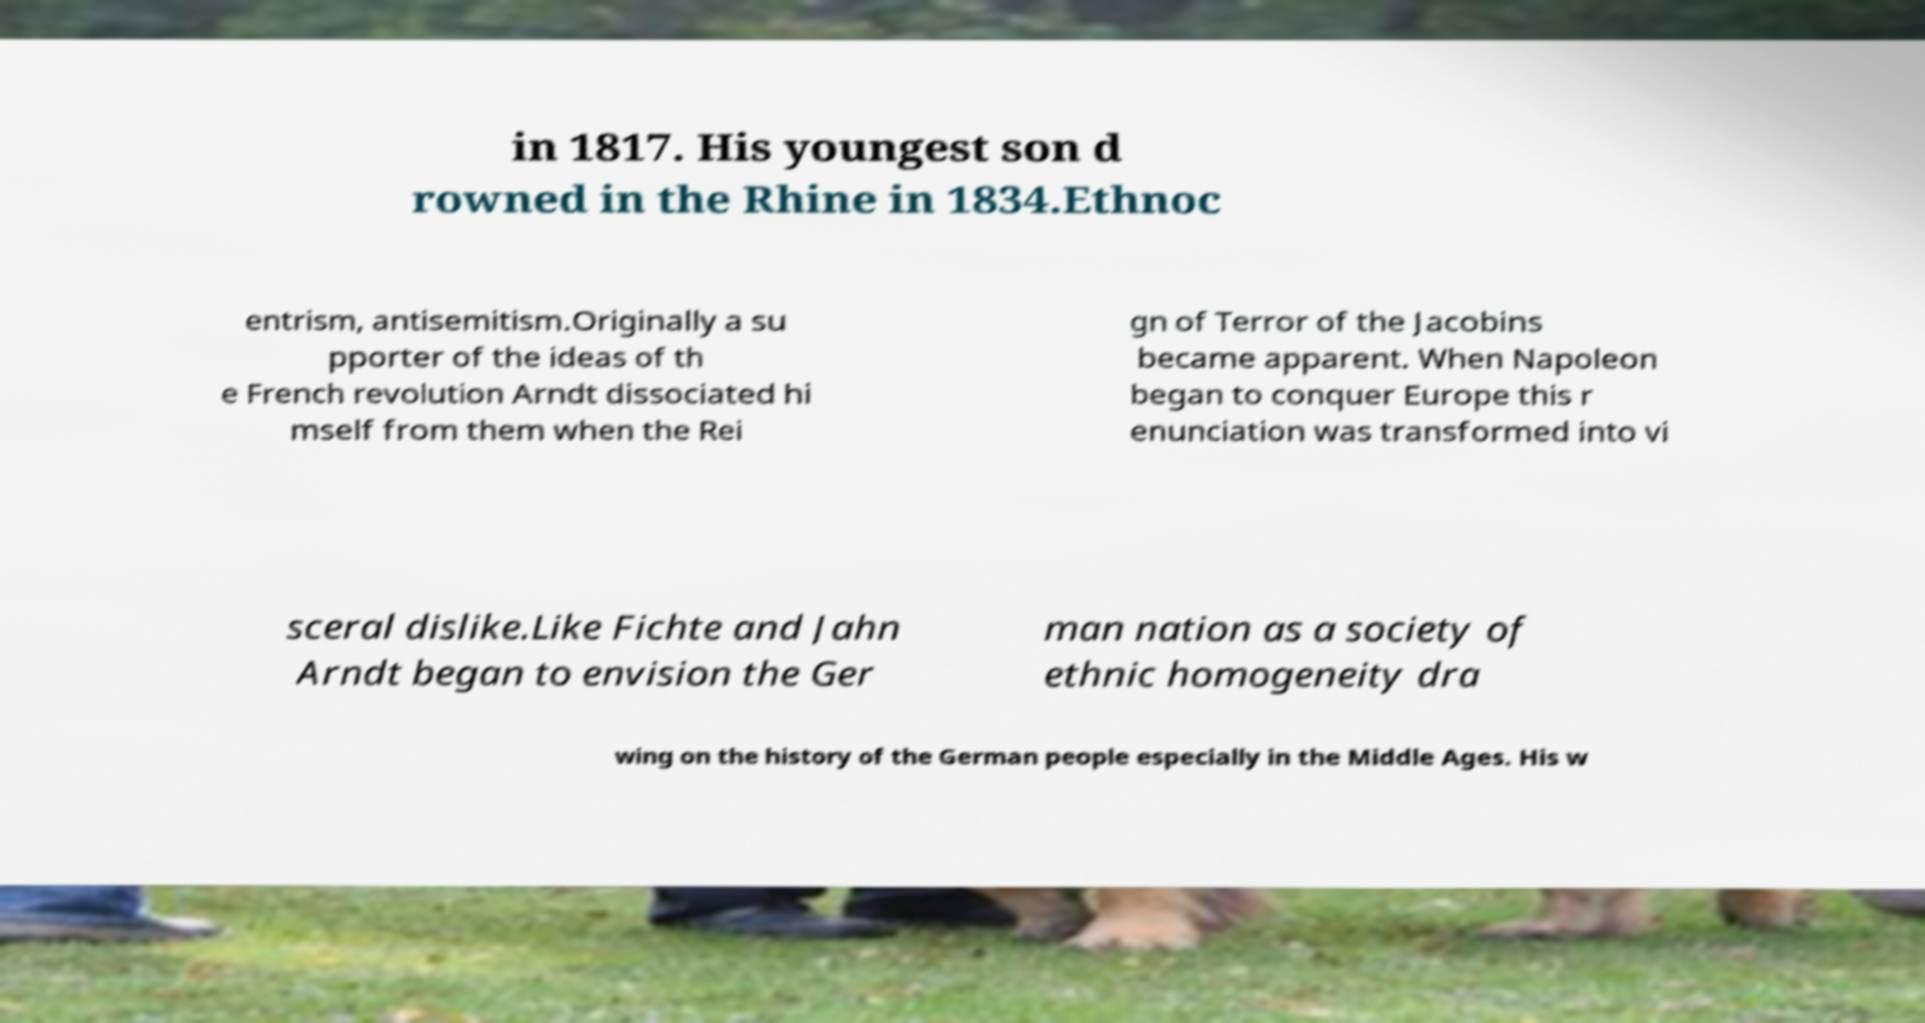There's text embedded in this image that I need extracted. Can you transcribe it verbatim? in 1817. His youngest son d rowned in the Rhine in 1834.Ethnoc entrism, antisemitism.Originally a su pporter of the ideas of th e French revolution Arndt dissociated hi mself from them when the Rei gn of Terror of the Jacobins became apparent. When Napoleon began to conquer Europe this r enunciation was transformed into vi sceral dislike.Like Fichte and Jahn Arndt began to envision the Ger man nation as a society of ethnic homogeneity dra wing on the history of the German people especially in the Middle Ages. His w 